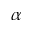<formula> <loc_0><loc_0><loc_500><loc_500>\alpha</formula> 